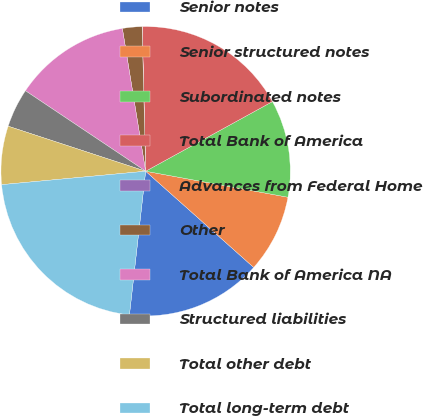Convert chart to OTSL. <chart><loc_0><loc_0><loc_500><loc_500><pie_chart><fcel>Senior notes<fcel>Senior structured notes<fcel>Subordinated notes<fcel>Total Bank of America<fcel>Advances from Federal Home<fcel>Other<fcel>Total Bank of America NA<fcel>Structured liabilities<fcel>Total other debt<fcel>Total long-term debt<nl><fcel>15.21%<fcel>8.7%<fcel>10.87%<fcel>17.39%<fcel>0.01%<fcel>2.18%<fcel>13.04%<fcel>4.35%<fcel>6.52%<fcel>21.73%<nl></chart> 